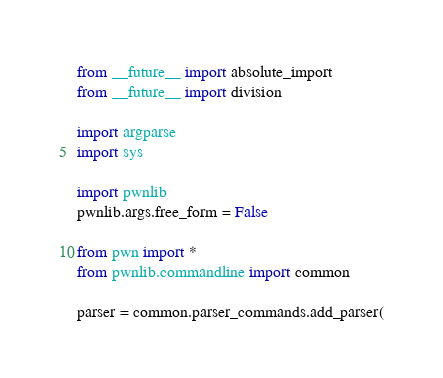Convert code to text. <code><loc_0><loc_0><loc_500><loc_500><_Python_>from __future__ import absolute_import
from __future__ import division

import argparse
import sys

import pwnlib
pwnlib.args.free_form = False

from pwn import *
from pwnlib.commandline import common

parser = common.parser_commands.add_parser(</code> 